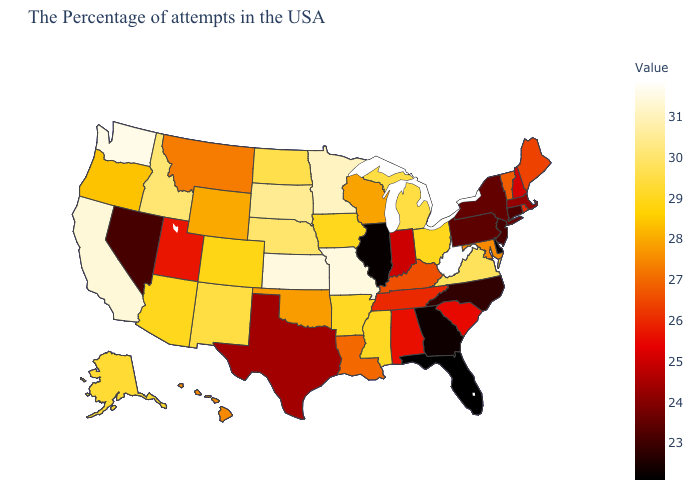Among the states that border Colorado , does Arizona have the lowest value?
Write a very short answer. No. Which states have the highest value in the USA?
Quick response, please. West Virginia. Which states hav the highest value in the MidWest?
Answer briefly. Missouri, Kansas. Does Ohio have a lower value than California?
Short answer required. Yes. Does Wyoming have the highest value in the USA?
Give a very brief answer. No. Which states hav the highest value in the MidWest?
Short answer required. Missouri, Kansas. Among the states that border North Dakota , which have the lowest value?
Concise answer only. Montana. 